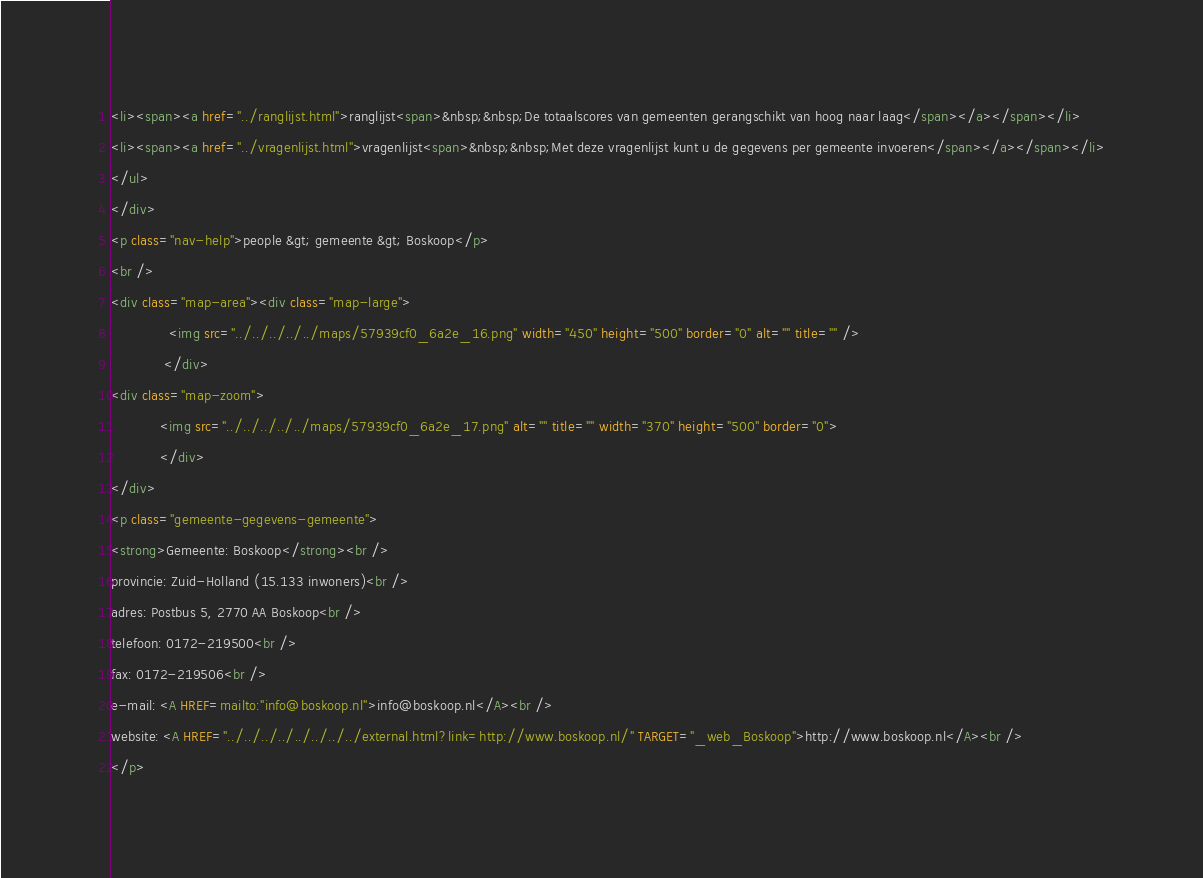<code> <loc_0><loc_0><loc_500><loc_500><_HTML_><li><span><a href="../ranglijst.html">ranglijst<span>&nbsp;&nbsp;De totaalscores van gemeenten gerangschikt van hoog naar laag</span></a></span></li>
<li><span><a href="../vragenlijst.html">vragenlijst<span>&nbsp;&nbsp;Met deze vragenlijst kunt u de gegevens per gemeente invoeren</span></a></span></li>
</ul>
</div>
<p class="nav-help">people &gt; gemeente &gt; Boskoop</p>
<br />
<div class="map-area"><div class="map-large">
              <img src="../../../../../maps/57939cf0_6a2e_16.png" width="450" height="500" border="0" alt="" title="" />
             </div>
<div class="map-zoom">
			<img src="../../../../../maps/57939cf0_6a2e_17.png" alt="" title="" width="370" height="500" border="0">
			</div>
</div>
<p class="gemeente-gegevens-gemeente">
<strong>Gemeente: Boskoop</strong><br />
provincie: Zuid-Holland (15.133 inwoners)<br />
adres: Postbus 5, 2770 AA Boskoop<br />
telefoon: 0172-219500<br />
fax: 0172-219506<br />
e-mail: <A HREF=mailto:"info@boskoop.nl">info@boskoop.nl</A><br />
website: <A HREF="../../../../../../../../external.html?link=http://www.boskoop.nl/" TARGET="_web_Boskoop">http://www.boskoop.nl</A><br />
</p></code> 